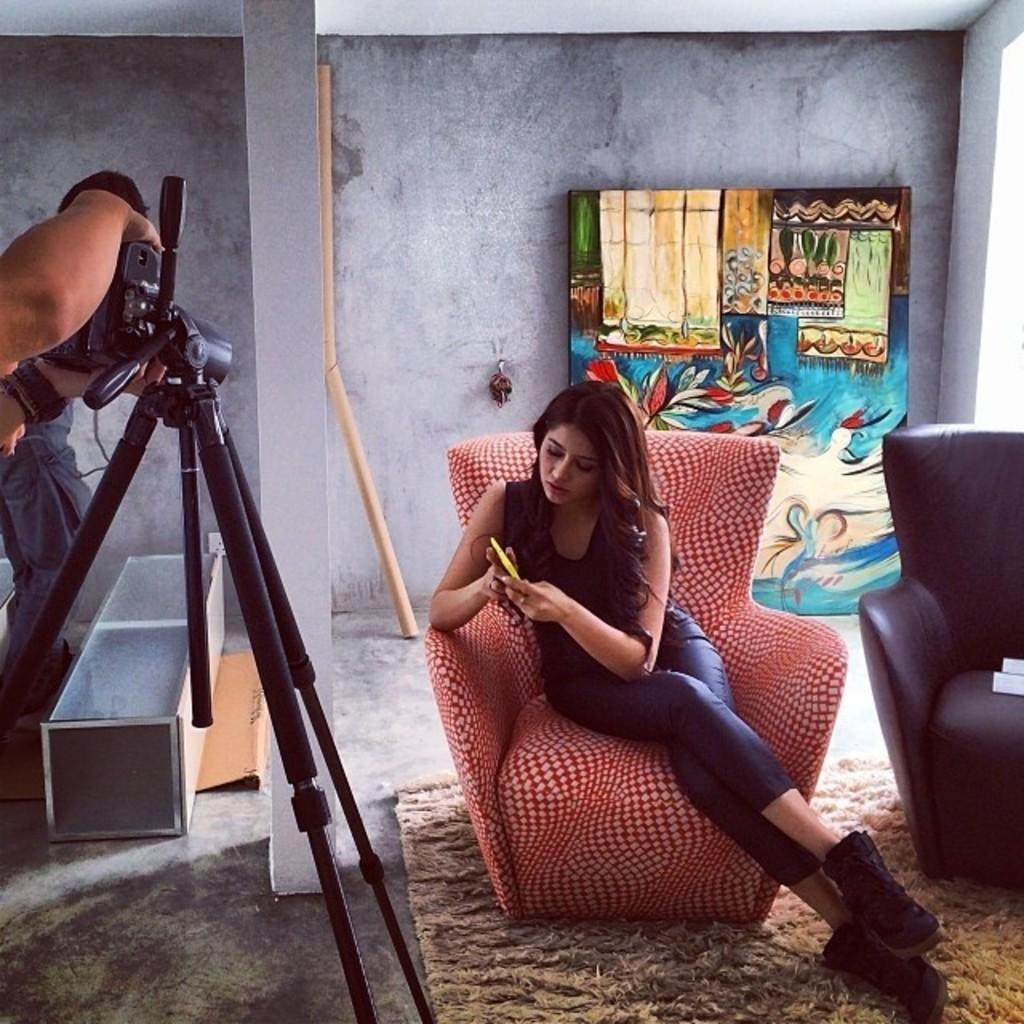Please provide a concise description of this image. In the middle there is a woman ,she is sitting on the chair ,she wear trouser and shoes ,her hair is short. on the left there is a man he is holding a camera. At the bottom there is a mat. In the background there is a painting and wall. I think this is a photoshoot. 